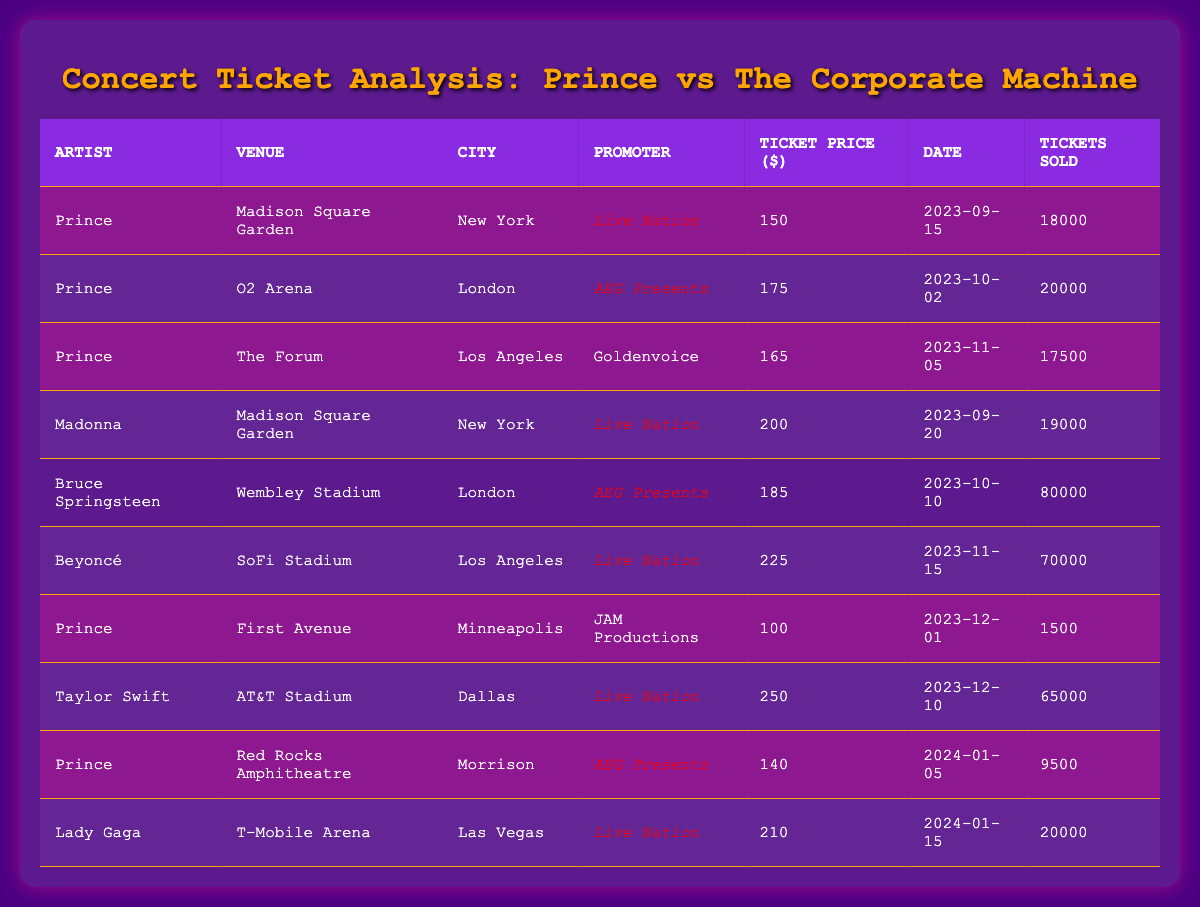What is the highest ticket price listed for Prince's concerts? The listed ticket prices for Prince's concerts are 150, 175, 165, 100, and 140. From these prices, 175 is the highest.
Answer: 175 How many tickets were sold for Beyoncé's concert? The table shows that 70,000 tickets were sold for Beyoncé's concert at SoFi Stadium in Los Angeles.
Answer: 70000 Which city had the highest ticket sales and for which artist? The highest ticket sales were 80,000, and they were for Bruce Springsteen's concert at Wembley Stadium in London.
Answer: Bruce Springsteen in London What was the average ticket price for all Prince concerts? The ticket prices for Prince are 150, 175, 165, 100, and 140. The sum of these prices is 730, and dividing by 5 gives an average of 146.
Answer: 146 Did Prince perform at Madison Square Garden? Yes, the data shows that Prince has performed at Madison Square Garden on September 15, 2023.
Answer: Yes How many more tickets were sold for Taylor Swift than for Prince's concert at First Avenue? Taylor Swift sold 65,000 tickets, and Prince sold 1,500 tickets at First Avenue. The difference is 65,000 - 1,500 = 63,500 tickets.
Answer: 63500 What is the total revenue from ticket sales for Prince's concert at The Forum? Prince's ticket price at The Forum was 165, and 17,500 tickets were sold. Therefore, the total revenue is 165 * 17,500 = 2,887,500.
Answer: 2887500 Which promoter had the highest ticket sales in the table? Analyzing the tickets sold, AEG Presents has 20,000 for Prince in London, 80,000 for Bruce Springsteen, and 9,500 for Prince at Red Rocks, totaling 109,500. Live Nation has 18,000 (Prince) + 19,000 (Madonna) + 70,000 (Beyoncé) + 65,000 (Taylor Swift) + 20,000 (Lady Gaga) = 192,000. Therefore, Live Nation had the highest ticket sales.
Answer: Live Nation What was the average ticket sales for Prince concerts? The tickets sold for Prince were 18,000, 20,000, 17,500, 1,500, and 9,500. The total sold is 66,500, and dividing this by 5 gives an average of 13,300.
Answer: 13300 